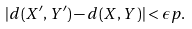Convert formula to latex. <formula><loc_0><loc_0><loc_500><loc_500>| d ( X ^ { \prime } , Y ^ { \prime } ) - d ( X , Y ) | < \epsilon p .</formula> 